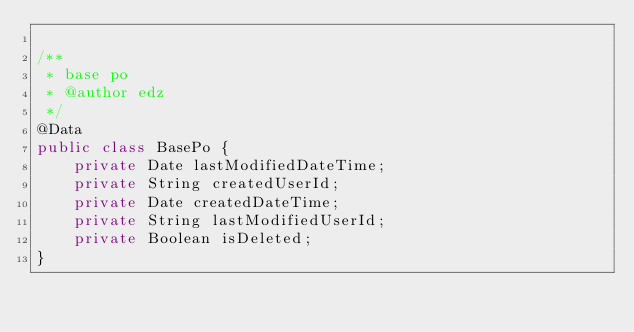Convert code to text. <code><loc_0><loc_0><loc_500><loc_500><_Java_>
/**
 * base po
 * @author edz
 */
@Data
public class BasePo {
    private Date lastModifiedDateTime;
    private String createdUserId;
    private Date createdDateTime;
    private String lastModifiedUserId;
    private Boolean isDeleted;
}
</code> 